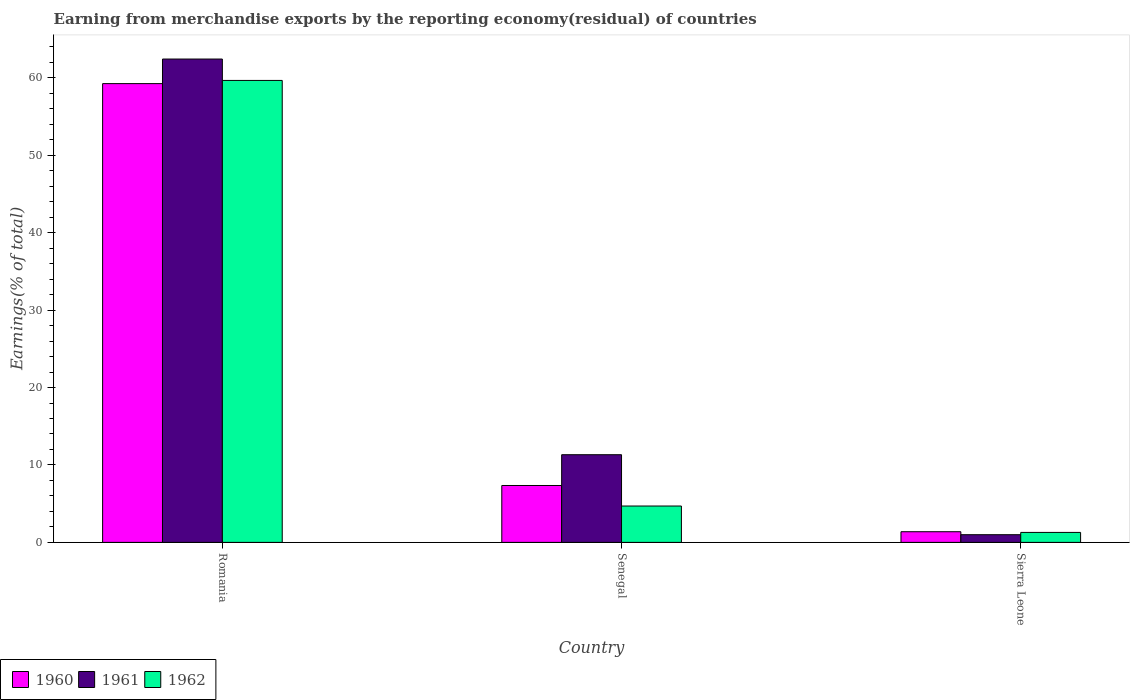How many different coloured bars are there?
Your answer should be very brief. 3. How many groups of bars are there?
Ensure brevity in your answer.  3. Are the number of bars on each tick of the X-axis equal?
Keep it short and to the point. Yes. How many bars are there on the 3rd tick from the left?
Offer a very short reply. 3. How many bars are there on the 2nd tick from the right?
Give a very brief answer. 3. What is the label of the 3rd group of bars from the left?
Keep it short and to the point. Sierra Leone. What is the percentage of amount earned from merchandise exports in 1960 in Romania?
Offer a very short reply. 59.26. Across all countries, what is the maximum percentage of amount earned from merchandise exports in 1961?
Your response must be concise. 62.43. Across all countries, what is the minimum percentage of amount earned from merchandise exports in 1960?
Provide a succinct answer. 1.38. In which country was the percentage of amount earned from merchandise exports in 1962 maximum?
Your answer should be compact. Romania. In which country was the percentage of amount earned from merchandise exports in 1962 minimum?
Make the answer very short. Sierra Leone. What is the total percentage of amount earned from merchandise exports in 1962 in the graph?
Offer a terse response. 65.65. What is the difference between the percentage of amount earned from merchandise exports in 1961 in Romania and that in Senegal?
Your answer should be very brief. 51.11. What is the difference between the percentage of amount earned from merchandise exports in 1960 in Sierra Leone and the percentage of amount earned from merchandise exports in 1961 in Senegal?
Offer a very short reply. -9.95. What is the average percentage of amount earned from merchandise exports in 1962 per country?
Offer a terse response. 21.88. What is the difference between the percentage of amount earned from merchandise exports of/in 1962 and percentage of amount earned from merchandise exports of/in 1960 in Senegal?
Provide a short and direct response. -2.65. In how many countries, is the percentage of amount earned from merchandise exports in 1961 greater than 6 %?
Provide a short and direct response. 2. What is the ratio of the percentage of amount earned from merchandise exports in 1961 in Romania to that in Senegal?
Give a very brief answer. 5.51. Is the percentage of amount earned from merchandise exports in 1960 in Romania less than that in Sierra Leone?
Give a very brief answer. No. What is the difference between the highest and the second highest percentage of amount earned from merchandise exports in 1962?
Keep it short and to the point. -58.38. What is the difference between the highest and the lowest percentage of amount earned from merchandise exports in 1961?
Make the answer very short. 61.44. In how many countries, is the percentage of amount earned from merchandise exports in 1962 greater than the average percentage of amount earned from merchandise exports in 1962 taken over all countries?
Give a very brief answer. 1. Is the sum of the percentage of amount earned from merchandise exports in 1961 in Senegal and Sierra Leone greater than the maximum percentage of amount earned from merchandise exports in 1962 across all countries?
Offer a terse response. No. What does the 2nd bar from the right in Romania represents?
Your answer should be compact. 1961. Is it the case that in every country, the sum of the percentage of amount earned from merchandise exports in 1962 and percentage of amount earned from merchandise exports in 1960 is greater than the percentage of amount earned from merchandise exports in 1961?
Offer a very short reply. Yes. What is the difference between two consecutive major ticks on the Y-axis?
Your response must be concise. 10. Are the values on the major ticks of Y-axis written in scientific E-notation?
Your answer should be very brief. No. Does the graph contain any zero values?
Keep it short and to the point. No. How many legend labels are there?
Keep it short and to the point. 3. How are the legend labels stacked?
Provide a succinct answer. Horizontal. What is the title of the graph?
Your answer should be very brief. Earning from merchandise exports by the reporting economy(residual) of countries. What is the label or title of the Y-axis?
Offer a very short reply. Earnings(% of total). What is the Earnings(% of total) in 1960 in Romania?
Make the answer very short. 59.26. What is the Earnings(% of total) in 1961 in Romania?
Your response must be concise. 62.43. What is the Earnings(% of total) in 1962 in Romania?
Make the answer very short. 59.67. What is the Earnings(% of total) in 1960 in Senegal?
Your answer should be compact. 7.35. What is the Earnings(% of total) of 1961 in Senegal?
Your response must be concise. 11.33. What is the Earnings(% of total) of 1962 in Senegal?
Ensure brevity in your answer.  4.7. What is the Earnings(% of total) in 1960 in Sierra Leone?
Provide a short and direct response. 1.38. What is the Earnings(% of total) of 1961 in Sierra Leone?
Ensure brevity in your answer.  0.99. What is the Earnings(% of total) in 1962 in Sierra Leone?
Keep it short and to the point. 1.29. Across all countries, what is the maximum Earnings(% of total) of 1960?
Make the answer very short. 59.26. Across all countries, what is the maximum Earnings(% of total) of 1961?
Keep it short and to the point. 62.43. Across all countries, what is the maximum Earnings(% of total) of 1962?
Offer a terse response. 59.67. Across all countries, what is the minimum Earnings(% of total) in 1960?
Your answer should be very brief. 1.38. Across all countries, what is the minimum Earnings(% of total) of 1961?
Provide a short and direct response. 0.99. Across all countries, what is the minimum Earnings(% of total) of 1962?
Provide a short and direct response. 1.29. What is the total Earnings(% of total) of 1960 in the graph?
Give a very brief answer. 67.98. What is the total Earnings(% of total) in 1961 in the graph?
Ensure brevity in your answer.  74.75. What is the total Earnings(% of total) of 1962 in the graph?
Ensure brevity in your answer.  65.65. What is the difference between the Earnings(% of total) of 1960 in Romania and that in Senegal?
Your answer should be compact. 51.91. What is the difference between the Earnings(% of total) in 1961 in Romania and that in Senegal?
Provide a short and direct response. 51.11. What is the difference between the Earnings(% of total) of 1962 in Romania and that in Senegal?
Your response must be concise. 54.97. What is the difference between the Earnings(% of total) in 1960 in Romania and that in Sierra Leone?
Provide a succinct answer. 57.88. What is the difference between the Earnings(% of total) in 1961 in Romania and that in Sierra Leone?
Offer a very short reply. 61.44. What is the difference between the Earnings(% of total) of 1962 in Romania and that in Sierra Leone?
Keep it short and to the point. 58.38. What is the difference between the Earnings(% of total) of 1960 in Senegal and that in Sierra Leone?
Offer a very short reply. 5.97. What is the difference between the Earnings(% of total) in 1961 in Senegal and that in Sierra Leone?
Give a very brief answer. 10.33. What is the difference between the Earnings(% of total) of 1962 in Senegal and that in Sierra Leone?
Keep it short and to the point. 3.41. What is the difference between the Earnings(% of total) of 1960 in Romania and the Earnings(% of total) of 1961 in Senegal?
Give a very brief answer. 47.93. What is the difference between the Earnings(% of total) of 1960 in Romania and the Earnings(% of total) of 1962 in Senegal?
Provide a short and direct response. 54.56. What is the difference between the Earnings(% of total) of 1961 in Romania and the Earnings(% of total) of 1962 in Senegal?
Provide a short and direct response. 57.74. What is the difference between the Earnings(% of total) of 1960 in Romania and the Earnings(% of total) of 1961 in Sierra Leone?
Provide a succinct answer. 58.27. What is the difference between the Earnings(% of total) of 1960 in Romania and the Earnings(% of total) of 1962 in Sierra Leone?
Make the answer very short. 57.97. What is the difference between the Earnings(% of total) of 1961 in Romania and the Earnings(% of total) of 1962 in Sierra Leone?
Provide a short and direct response. 61.15. What is the difference between the Earnings(% of total) of 1960 in Senegal and the Earnings(% of total) of 1961 in Sierra Leone?
Your answer should be very brief. 6.35. What is the difference between the Earnings(% of total) in 1960 in Senegal and the Earnings(% of total) in 1962 in Sierra Leone?
Offer a terse response. 6.06. What is the difference between the Earnings(% of total) of 1961 in Senegal and the Earnings(% of total) of 1962 in Sierra Leone?
Make the answer very short. 10.04. What is the average Earnings(% of total) in 1960 per country?
Offer a very short reply. 22.66. What is the average Earnings(% of total) in 1961 per country?
Keep it short and to the point. 24.92. What is the average Earnings(% of total) in 1962 per country?
Offer a very short reply. 21.88. What is the difference between the Earnings(% of total) of 1960 and Earnings(% of total) of 1961 in Romania?
Offer a very short reply. -3.17. What is the difference between the Earnings(% of total) of 1960 and Earnings(% of total) of 1962 in Romania?
Your answer should be very brief. -0.41. What is the difference between the Earnings(% of total) of 1961 and Earnings(% of total) of 1962 in Romania?
Offer a terse response. 2.76. What is the difference between the Earnings(% of total) in 1960 and Earnings(% of total) in 1961 in Senegal?
Your answer should be very brief. -3.98. What is the difference between the Earnings(% of total) in 1960 and Earnings(% of total) in 1962 in Senegal?
Your response must be concise. 2.65. What is the difference between the Earnings(% of total) of 1961 and Earnings(% of total) of 1962 in Senegal?
Your response must be concise. 6.63. What is the difference between the Earnings(% of total) in 1960 and Earnings(% of total) in 1961 in Sierra Leone?
Provide a short and direct response. 0.38. What is the difference between the Earnings(% of total) of 1960 and Earnings(% of total) of 1962 in Sierra Leone?
Offer a very short reply. 0.09. What is the difference between the Earnings(% of total) of 1961 and Earnings(% of total) of 1962 in Sierra Leone?
Provide a succinct answer. -0.29. What is the ratio of the Earnings(% of total) in 1960 in Romania to that in Senegal?
Ensure brevity in your answer.  8.06. What is the ratio of the Earnings(% of total) in 1961 in Romania to that in Senegal?
Your answer should be compact. 5.51. What is the ratio of the Earnings(% of total) of 1962 in Romania to that in Senegal?
Offer a terse response. 12.71. What is the ratio of the Earnings(% of total) of 1960 in Romania to that in Sierra Leone?
Ensure brevity in your answer.  43.02. What is the ratio of the Earnings(% of total) of 1961 in Romania to that in Sierra Leone?
Give a very brief answer. 62.88. What is the ratio of the Earnings(% of total) of 1962 in Romania to that in Sierra Leone?
Your answer should be compact. 46.34. What is the ratio of the Earnings(% of total) of 1960 in Senegal to that in Sierra Leone?
Keep it short and to the point. 5.33. What is the ratio of the Earnings(% of total) in 1961 in Senegal to that in Sierra Leone?
Keep it short and to the point. 11.41. What is the ratio of the Earnings(% of total) in 1962 in Senegal to that in Sierra Leone?
Your answer should be very brief. 3.65. What is the difference between the highest and the second highest Earnings(% of total) of 1960?
Give a very brief answer. 51.91. What is the difference between the highest and the second highest Earnings(% of total) of 1961?
Keep it short and to the point. 51.11. What is the difference between the highest and the second highest Earnings(% of total) of 1962?
Your answer should be compact. 54.97. What is the difference between the highest and the lowest Earnings(% of total) of 1960?
Your response must be concise. 57.88. What is the difference between the highest and the lowest Earnings(% of total) in 1961?
Your answer should be very brief. 61.44. What is the difference between the highest and the lowest Earnings(% of total) in 1962?
Provide a succinct answer. 58.38. 